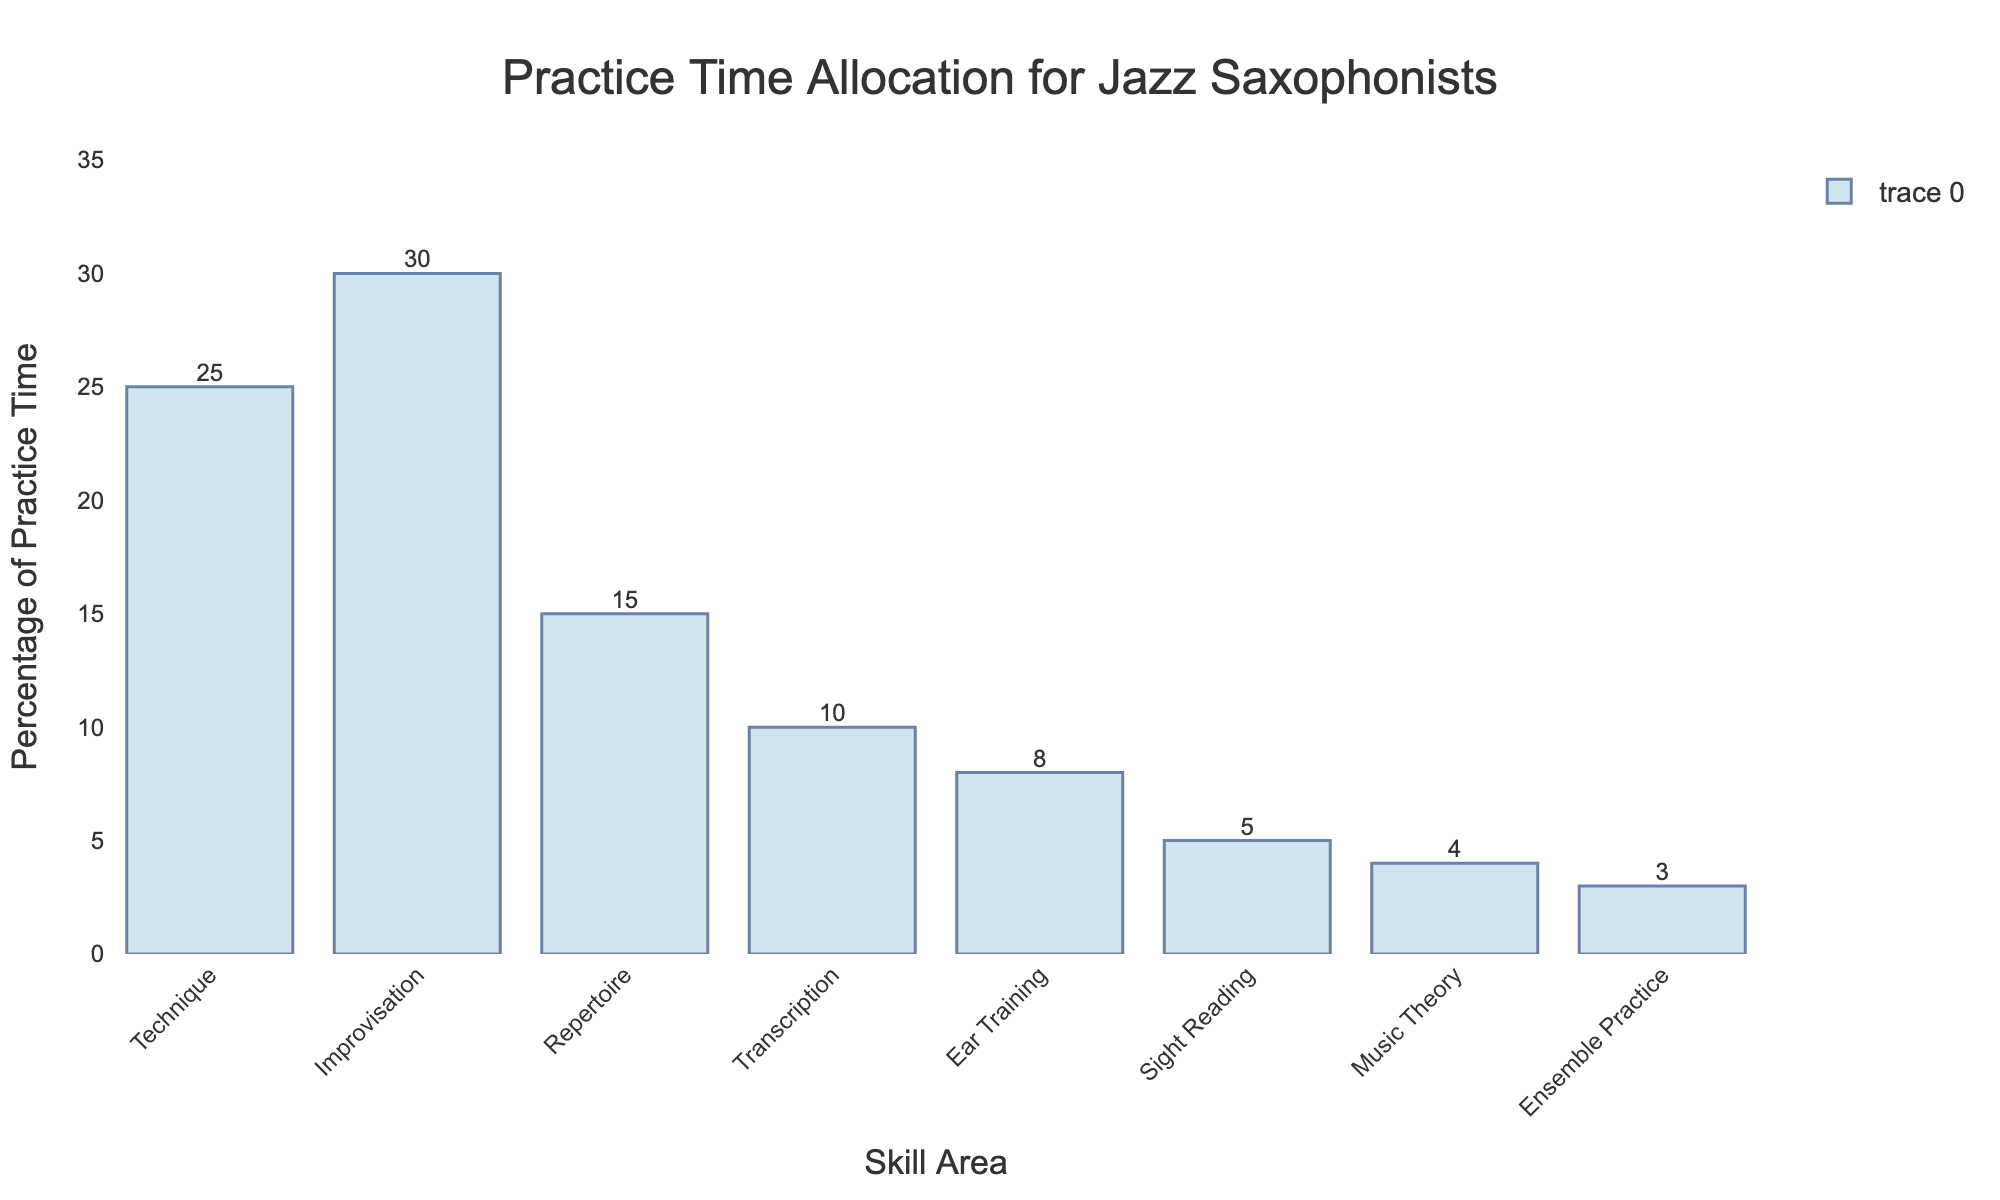How much more practice time is allocated to improvisation compared to music theory? Subtract the percentage of practice time for music theory (4%) from the percentage for improvisation (30%). 30% - 4% = 26%.
Answer: 26% Which skill area receives the least amount of practice time? The bar corresponding to Ensemble Practice is the shortest at 3%, making it the area with the least practice time.
Answer: Ensemble Practice What is the total percentage of practice time dedicated to Technique, Ear Training, and Sight Reading combined? Sum the percentages for Technique (25%), Ear Training (8%), and Sight Reading (5%). 25% + 8% + 5% = 38%.
Answer: 38% Are there more areas with 10% or more practice time or with less than 10% practice time? Count the number of areas with 10% or more practice time (Technique, Improvisation, Repertoire - 3) and compare it to areas with less than 10% (Transcription, Ear Training, Sight Reading, Music Theory, Ensemble Practice - 5). 3 < 5.
Answer: Less than 10% Which two skill areas, when combined, equal the same percentage of practice time as Improvisation? Combine Technique (25%) and Music Theory (4%). 25% + 4% is just below 30%, but Technique (25%) and Transcription (10%) yield 35%. Thus, no direct sum equals Improvisation (30%).
Answer: None Which skill area has double the practice time of Sight Reading? Sight Reading has 5%, so we look for 5% x 2 = 10%. The skill area with 10% is Transcription.
Answer: Transcription What is the average practice time across all skill areas? Add all percentages and divide by the number of skill areas: (25+30+15+10+8+5+4+3)/8 = 100/8 = 12.5%.
Answer: 12.5% Which skill area’s practice time percentage is closest to 20%? Compare each bar to 20%. Technique is 25% (5% away), and Repertoire is 15% (also 5% away). Thus, Technique and Repertoire are equidistant to 20%.
Answer: Technique and Repertoire What percentage more practice time is dedicated to Improvisation than to Repertoire? Subtract Repertoire (15%) from Improvisation (30%). 30% - 15% = 15%.
Answer: 15% How does the practice time allocation for Technique compare visually to the allocation for Repertoire? The bar for Technique (25%) is longer than the bar for Repertoire (15%), indicating more practice time is allocated to Technique.
Answer: Longer/More 